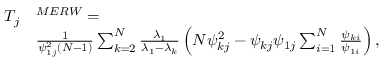<formula> <loc_0><loc_0><loc_500><loc_500>\begin{array} { r l } { T _ { j } } & { ^ { M E R W } = } \\ & { \frac { 1 } { \psi _ { 1 j } ^ { 2 } ( N - 1 ) } \sum _ { k = 2 } ^ { N } \frac { \lambda _ { 1 } } { \lambda _ { 1 } - \lambda _ { k } } \left ( N \psi _ { k j } ^ { 2 } - \psi _ { k j } \psi _ { 1 j } \sum _ { i = 1 } ^ { N } \frac { \psi _ { k i } } { \psi _ { 1 i } } \right ) , } \end{array}</formula> 